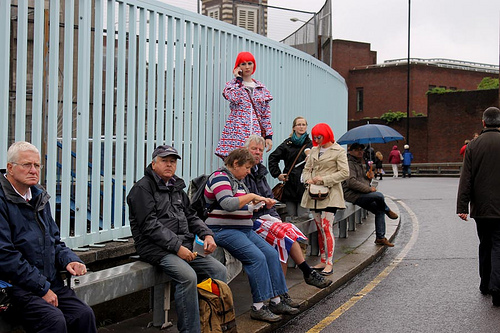<image>
Is the man on the lady? No. The man is not positioned on the lady. They may be near each other, but the man is not supported by or resting on top of the lady. Is there a girl behind the man? Yes. From this viewpoint, the girl is positioned behind the man, with the man partially or fully occluding the girl. 